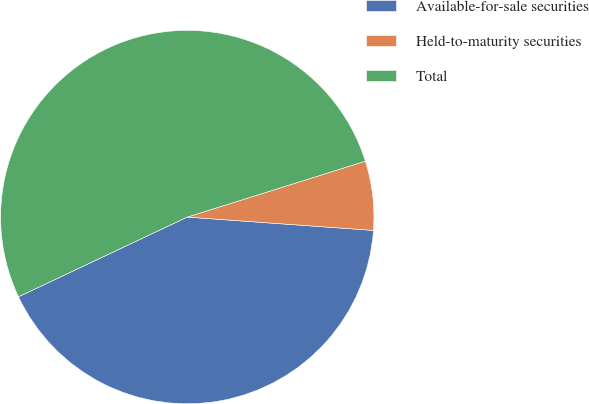Convert chart. <chart><loc_0><loc_0><loc_500><loc_500><pie_chart><fcel>Available-for-sale securities<fcel>Held-to-maturity securities<fcel>Total<nl><fcel>41.84%<fcel>5.98%<fcel>52.18%<nl></chart> 